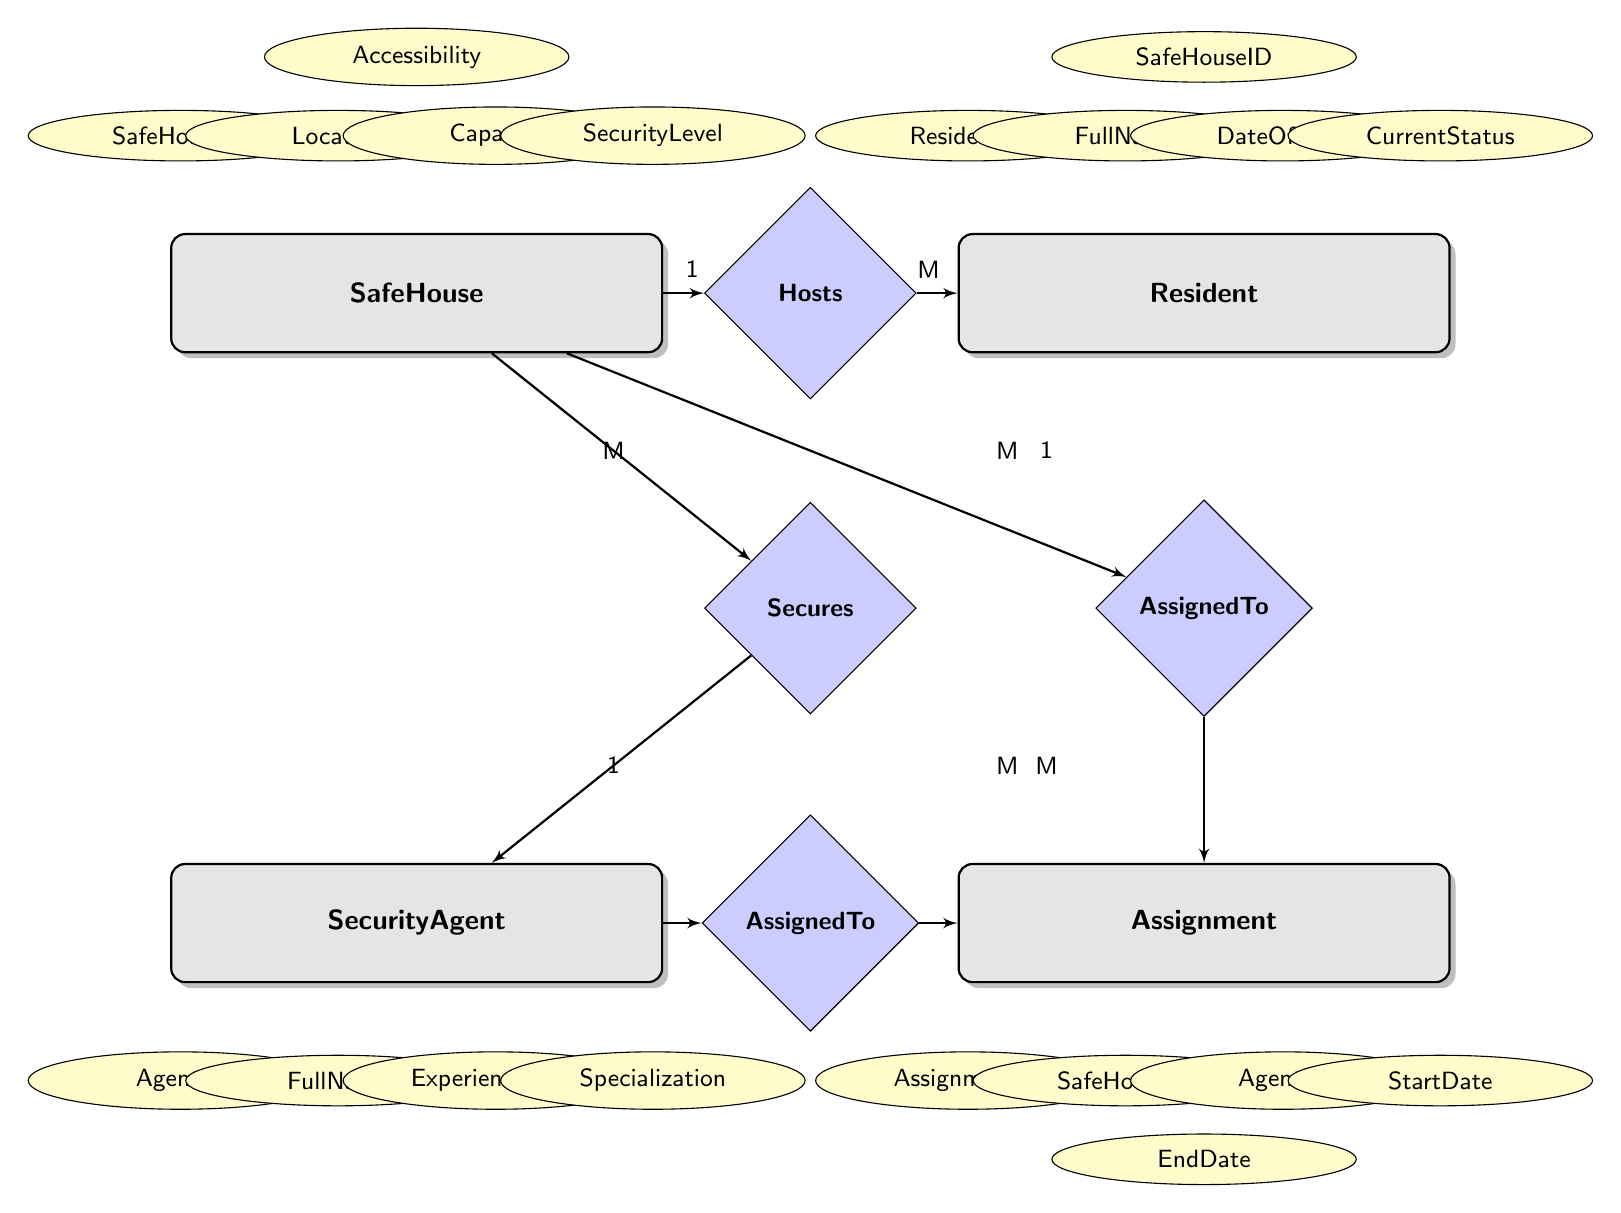What is the primary entity that hosts residents? The diagram indicates that the "SafeHouse" entity has a relationship with "Resident" through the "Hosts" connection. This means that SafeHouse is the primary entity that hosts residents.
Answer: SafeHouse How many attributes does the SecurityAgent entity have? Looking at the "SecurityAgent" entity in the diagram, it has four attributes listed: AgentID, FullName, ExperienceLevel, and Specialization.
Answer: 4 What is the relationship type between SecurityAgent and SafeHouse? In the diagram, the relationship between "SecurityAgent" and "SafeHouse" is labeled as "Secures," and this connection is depicted as ManyToMany, indicating that multiple agents can secure multiple safe houses.
Answer: ManyToMany How many residents can a single SafeHouse host? The "Hosts" relationship indicates a OneToMany relationship between "SafeHouse" and "Resident." This means a single SafeHouse can host many residents, but the exact number is determined by the "Capacity" attribute of the SafeHouse entity.
Answer: Many Which entity is associated with assignment identification? The "Assignment" entity has an attribute specifically named "AssignmentID," which represents the identification related to the assignments.
Answer: Assignment What is the cardinality between SafeHouse and Assignment? The diagram shows a OneToMany relationship labeled "AssignedTo" between "SafeHouse" and "Assignment." This means each SafeHouse can be associated with multiple assignments.
Answer: OneToMany Which entity is linked to the CurrentStatus attribute? The "CurrentStatus" attribute is part of the "Resident" entity, indicating that the status of a resident is tracked within this entity.
Answer: Resident How many entities are present in this diagram? The diagram contains four main entities: SafeHouse, Resident, SecurityAgent, and Assignment.
Answer: 4 In which relationship does the SafeHouse and SecurityAgent intersect? The intersection between "SafeHouse" and "SecurityAgent" is represented by the "Secures" relationship, indicating the connection between these two entities in the context of the diagram.
Answer: Secures 